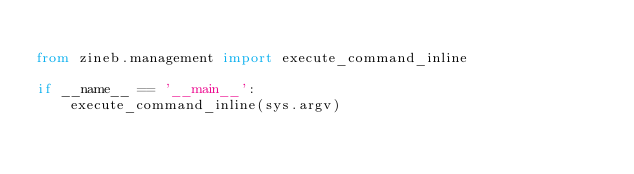<code> <loc_0><loc_0><loc_500><loc_500><_Python_>
from zineb.management import execute_command_inline

if __name__ == '__main__':
    execute_command_inline(sys.argv)
</code> 